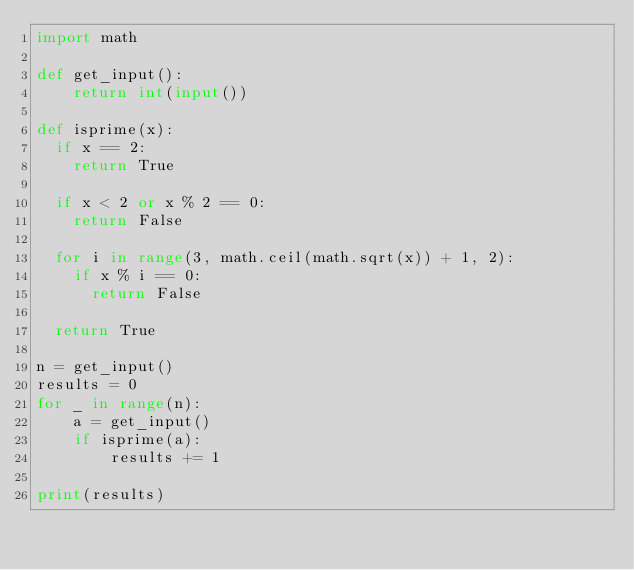Convert code to text. <code><loc_0><loc_0><loc_500><loc_500><_Python_>import math

def get_input():
    return int(input())

def isprime(x):
  if x == 2:
    return True

  if x < 2 or x % 2 == 0:
    return False

  for i in range(3, math.ceil(math.sqrt(x)) + 1, 2):
    if x % i == 0:
      return False

  return True

n = get_input()
results = 0
for _ in range(n):
    a = get_input()
    if isprime(a):
        results += 1

print(results)

</code> 